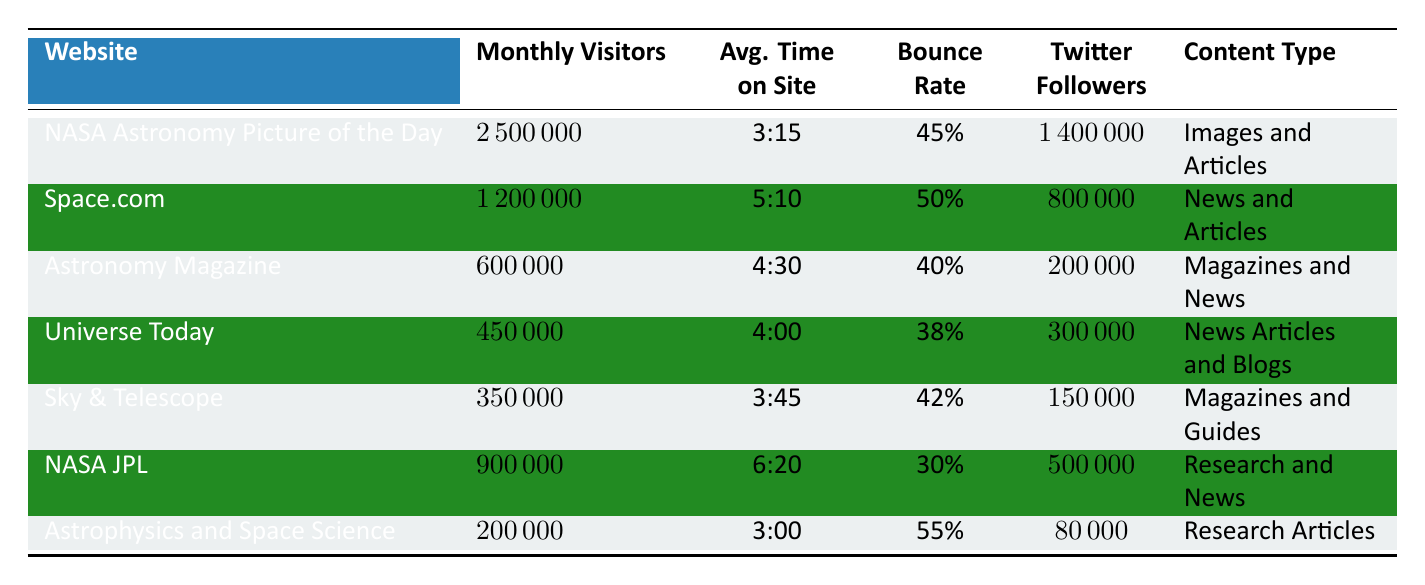What is the website with the highest monthly visitors? Looking at the 'Monthly Visitors' column in the table, 'NASA Astronomy Picture of the Day' has 2,500,000 visitors, which is higher than any other website listed.
Answer: NASA Astronomy Picture of the Day What is the average time on site for Space.com? Referring to the 'Avg. Time on Site' column, Space.com has an average of 5 minutes and 10 seconds on the site.
Answer: 5:10 Which website has the lowest bounce rate? In the 'Bounce Rate' column, the lowest percentage is 30%, which is associated with 'NASA JPL.'
Answer: NASA JPL How many total Twitter followers do the websites collectively have? By summing the 'Twitter Followers' values: 1,400,000 (NASA) + 800,000 (Space.com) + 200,000 (Astronomy Magazine) + 300,000 (Universe Today) + 150,000 (Sky & Telescope) + 500,000 (NASA JPL) + 80,000 (Astrophysics) = 3,430,000.
Answer: 3,430,000 Is the average time on site greater for 'NASA JPL' compared to 'Universe Today'? 'NASA JPL' has an average time of 6 minutes and 20 seconds, while 'Universe Today' has 4 minutes. Since 6:20 is greater than 4:00, the statement is true.
Answer: Yes Which website has the highest number of Facebook followers? The 'Facebook Followers' column shows that 'NASA Astronomy Picture of the Day' has 1,800,000 followers, which is the highest among the websites listed.
Answer: NASA Astronomy Picture of the Day How does the monthly visitors count of 'Astrophysics and Space Science' compare to that of 'Sky & Telescope'? 'Astrophysics and Space Science' has 200,000 monthly visitors, whereas 'Sky & Telescope' has 350,000. Calculating the difference, 350,000 - 200,000 = 150,000, so 'Sky & Telescope' has 150,000 more visitors.
Answer: 150,000 more What percentage of visitors bounce off from 'NASA JPL'? The bounce rate for 'NASA JPL' is 30%, which can be directly retrieved from the 'Bounce Rate' column.
Answer: 30% How does the average time on site for 'NASA JPL' compare to the overall average of the other websites shown? The average time on site for 'NASA JPL' is 6:20, and the average for the other websites is calculated by summing their times [(3:15 + 5:10 + 4:30 + 4:00 + 3:45 + 3:00)/6], which is about 4:00. Since 6:20 is greater than 4:00, 'NASA JPL' has a higher average time on site.
Answer: Higher Are there more visitors on average for websites focused on images and articles than those focused on research articles? The average monthly visitors for 'NASA Astronomy Picture of the Day' (2,500,000) and 'Space.com' (1,200,000) focused on images and news articles is (2,500,000 + 1,200,000) / 2 = 1,850,000; for 'Astrophysics and Space Science' (200,000). Since 1,850,000 > 200,000, there are more visitors on average for the former.
Answer: Yes 